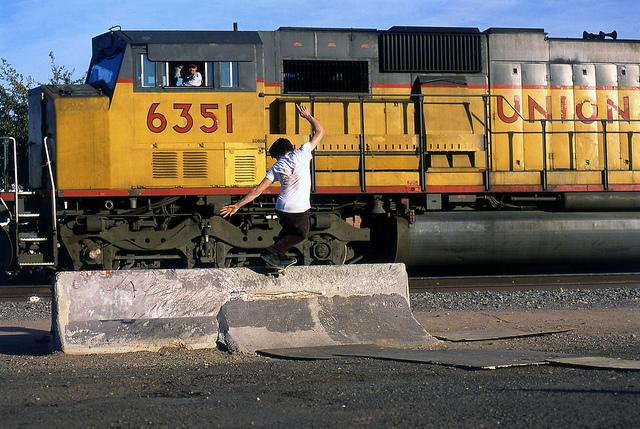Which direction did the skater just come from? Please explain your reasoning. down. There is a curved ramp-type structure behind the skater, which he used to rise up in the air for his trick. 